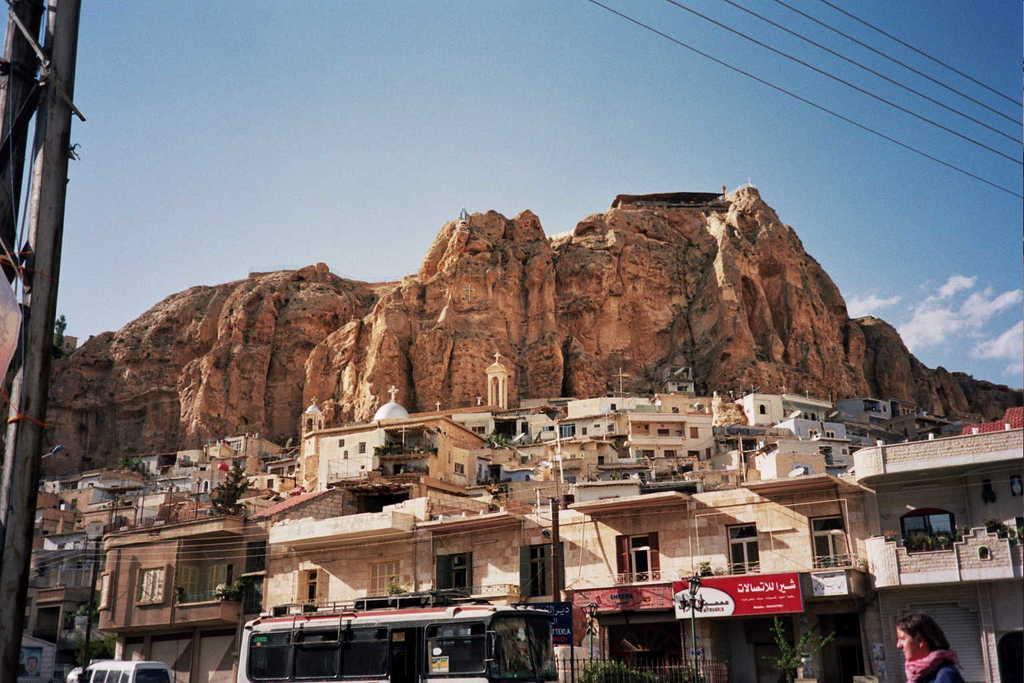Can you describe this image briefly? In this image there are buildings, few vehicles are moving on the road and we can see there is a lady and poles. In the background there are mountains and the sky. 